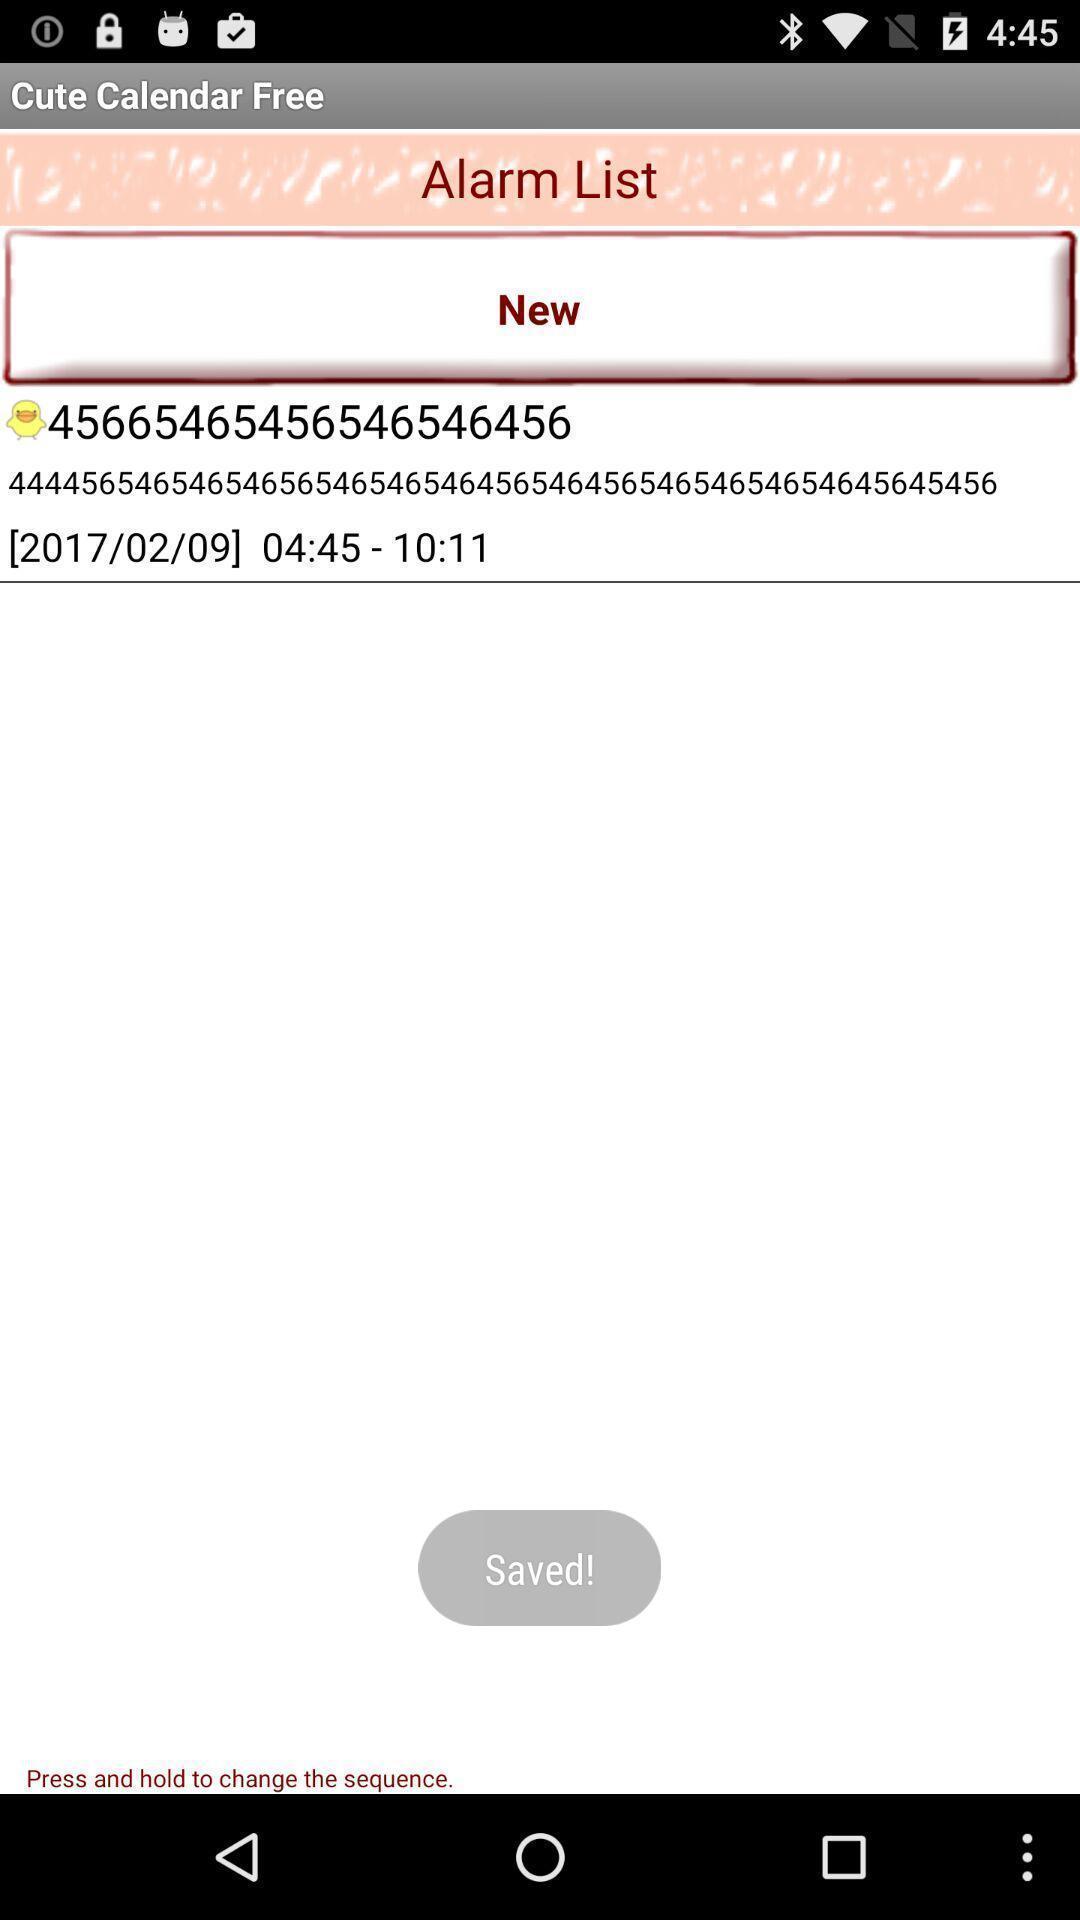Summarize the information in this screenshot. Page showing alarm list of calendar app. 